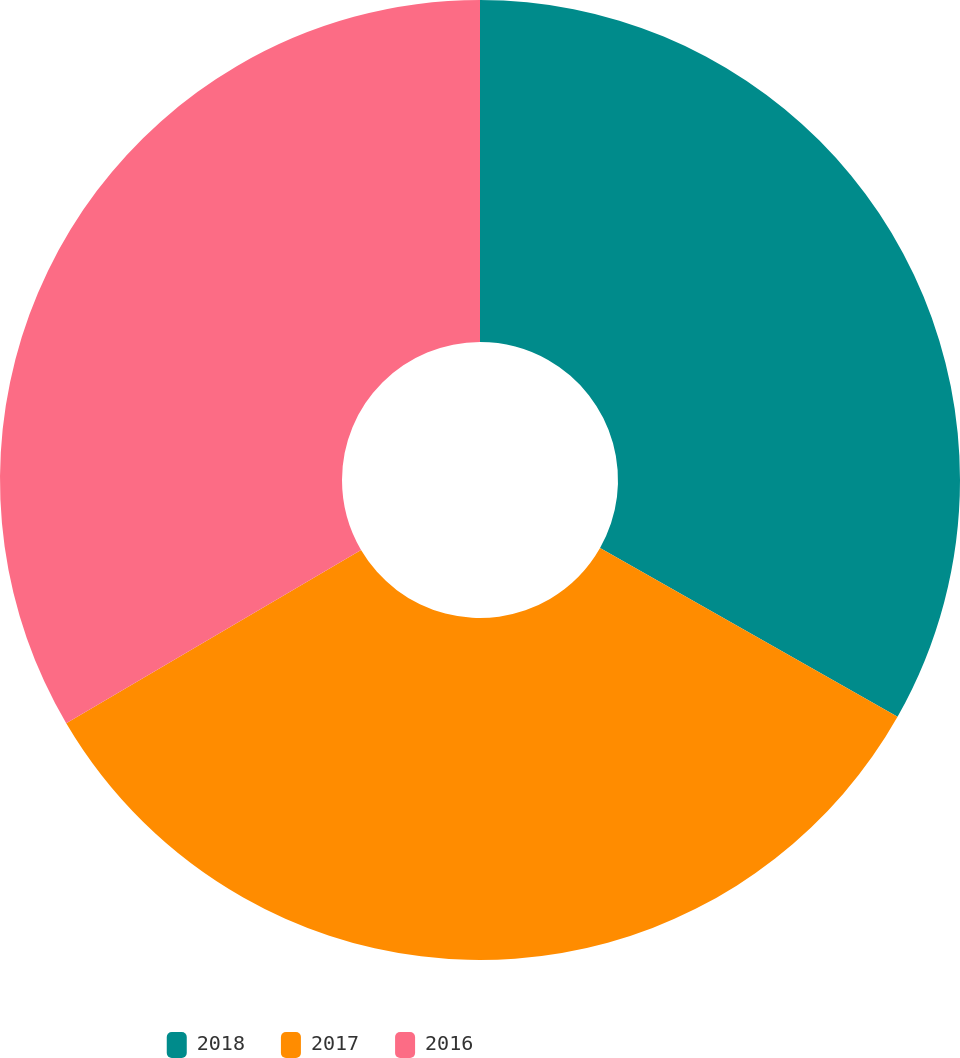<chart> <loc_0><loc_0><loc_500><loc_500><pie_chart><fcel>2018<fcel>2017<fcel>2016<nl><fcel>33.21%<fcel>33.33%<fcel>33.46%<nl></chart> 